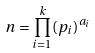<formula> <loc_0><loc_0><loc_500><loc_500>n = \prod _ { i = 1 } ^ { k } ( p _ { i } ) ^ { a _ { i } }</formula> 